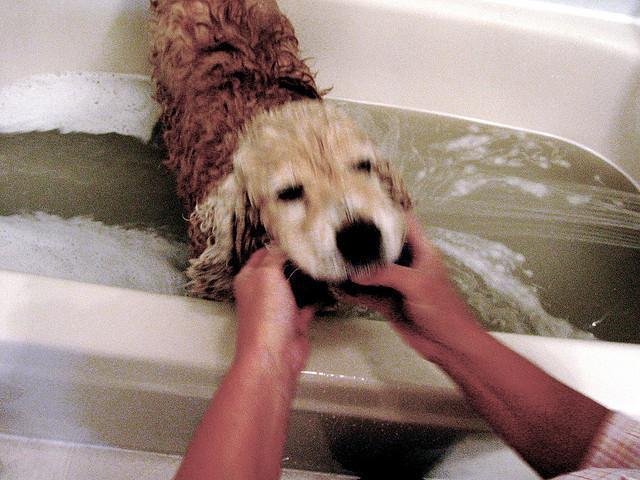How many chairs are at the table?
Give a very brief answer. 0. 